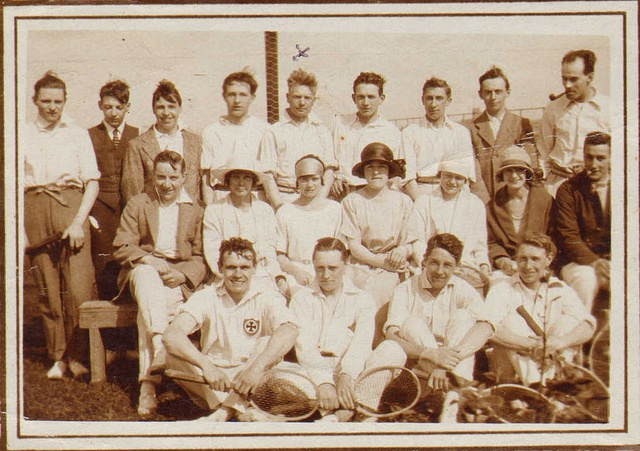Describe the objects in this image and their specific colors. I can see people in maroon, lightgray, and tan tones, people in maroon, lightgray, gray, and brown tones, people in maroon, tan, and lightgray tones, tennis racket in maroon, brown, and tan tones, and people in maroon, black, and tan tones in this image. 